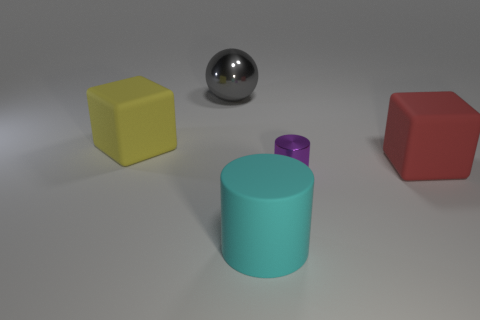Add 1 brown balls. How many objects exist? 6 Subtract all blocks. How many objects are left? 3 Add 3 large cyan rubber cylinders. How many large cyan rubber cylinders exist? 4 Subtract 0 purple cubes. How many objects are left? 5 Subtract all big gray metal things. Subtract all matte blocks. How many objects are left? 2 Add 3 cubes. How many cubes are left? 5 